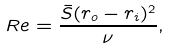Convert formula to latex. <formula><loc_0><loc_0><loc_500><loc_500>R e = \frac { \bar { S } ( r _ { o } - r _ { i } ) ^ { 2 } } { \nu } ,</formula> 